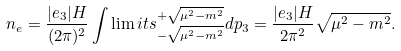Convert formula to latex. <formula><loc_0><loc_0><loc_500><loc_500>n _ { e } = \frac { | e _ { 3 } | H } { ( 2 \pi ) ^ { 2 } } \int \lim i t s ^ { + \sqrt { \mu ^ { 2 } - m ^ { 2 } } } _ { - \sqrt { \mu ^ { 2 } - m ^ { 2 } } } d p _ { 3 } = \frac { | e _ { 3 } | H } { 2 \pi ^ { 2 } } \sqrt { \mu ^ { 2 } - m ^ { 2 } } .</formula> 